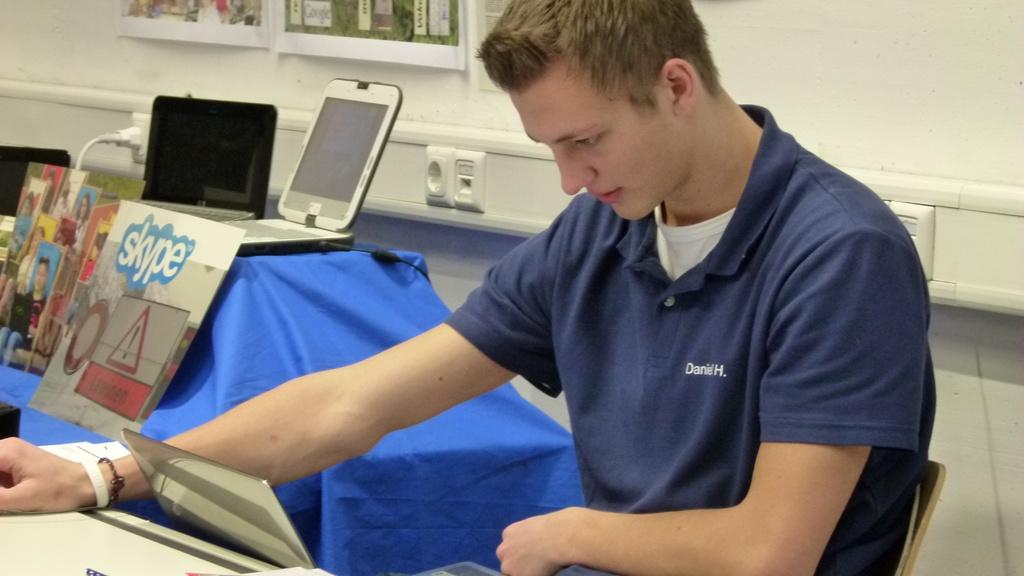<image>
Give a short and clear explanation of the subsequent image. A young man looks at a laptop wearing a blue shirt that reads Daniel H on his left. 